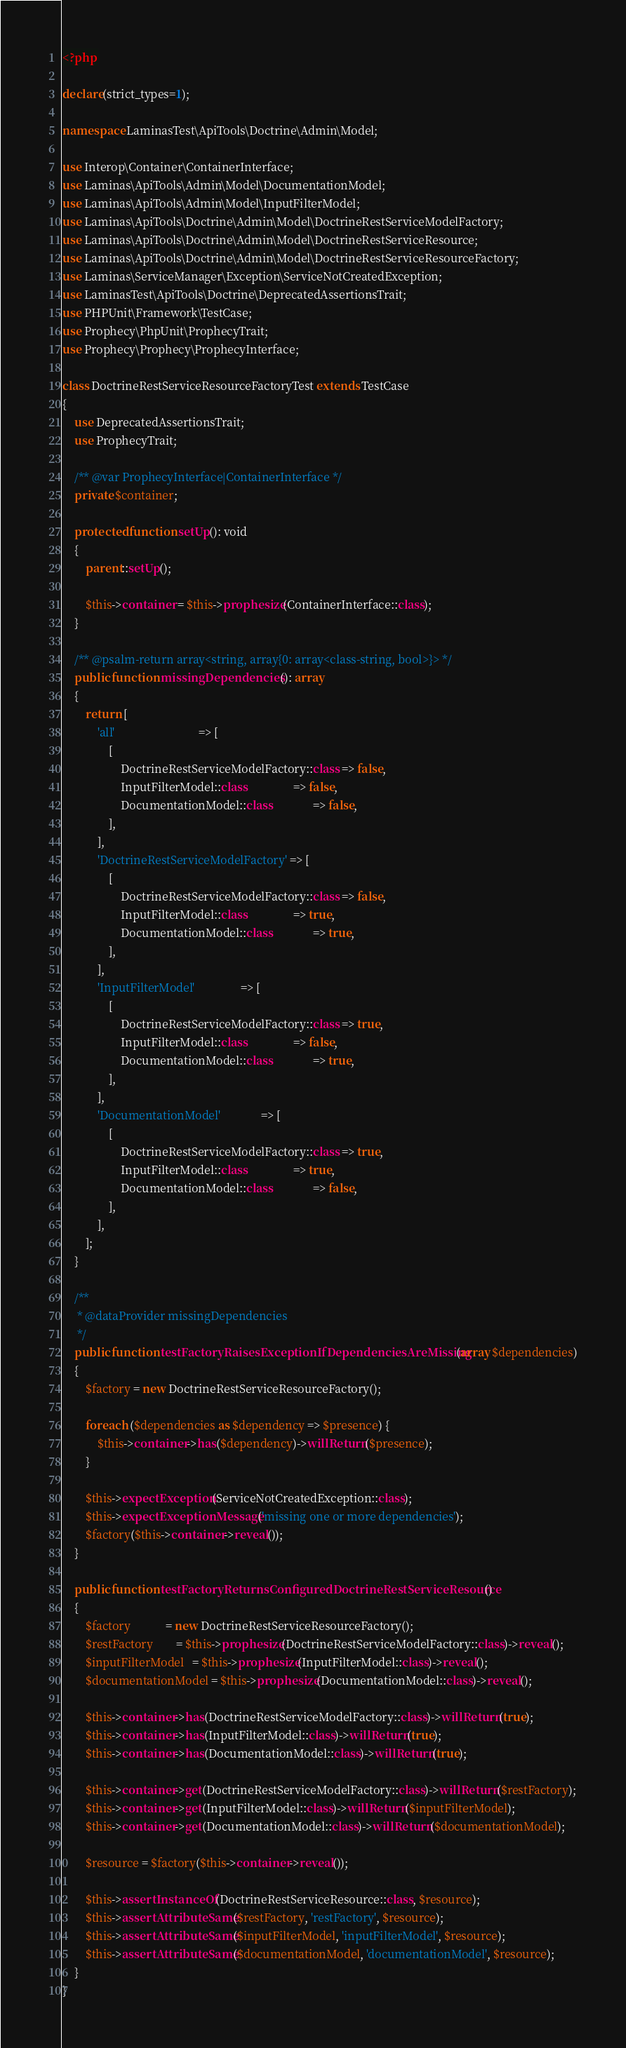<code> <loc_0><loc_0><loc_500><loc_500><_PHP_><?php

declare(strict_types=1);

namespace LaminasTest\ApiTools\Doctrine\Admin\Model;

use Interop\Container\ContainerInterface;
use Laminas\ApiTools\Admin\Model\DocumentationModel;
use Laminas\ApiTools\Admin\Model\InputFilterModel;
use Laminas\ApiTools\Doctrine\Admin\Model\DoctrineRestServiceModelFactory;
use Laminas\ApiTools\Doctrine\Admin\Model\DoctrineRestServiceResource;
use Laminas\ApiTools\Doctrine\Admin\Model\DoctrineRestServiceResourceFactory;
use Laminas\ServiceManager\Exception\ServiceNotCreatedException;
use LaminasTest\ApiTools\Doctrine\DeprecatedAssertionsTrait;
use PHPUnit\Framework\TestCase;
use Prophecy\PhpUnit\ProphecyTrait;
use Prophecy\Prophecy\ProphecyInterface;

class DoctrineRestServiceResourceFactoryTest extends TestCase
{
    use DeprecatedAssertionsTrait;
    use ProphecyTrait;

    /** @var ProphecyInterface|ContainerInterface */
    private $container;

    protected function setUp(): void
    {
        parent::setUp();

        $this->container = $this->prophesize(ContainerInterface::class);
    }

    /** @psalm-return array<string, array{0: array<class-string, bool>}> */
    public function missingDependencies(): array
    {
        return [
            'all'                             => [
                [
                    DoctrineRestServiceModelFactory::class => false,
                    InputFilterModel::class                => false,
                    DocumentationModel::class              => false,
                ],
            ],
            'DoctrineRestServiceModelFactory' => [
                [
                    DoctrineRestServiceModelFactory::class => false,
                    InputFilterModel::class                => true,
                    DocumentationModel::class              => true,
                ],
            ],
            'InputFilterModel'                => [
                [
                    DoctrineRestServiceModelFactory::class => true,
                    InputFilterModel::class                => false,
                    DocumentationModel::class              => true,
                ],
            ],
            'DocumentationModel'              => [
                [
                    DoctrineRestServiceModelFactory::class => true,
                    InputFilterModel::class                => true,
                    DocumentationModel::class              => false,
                ],
            ],
        ];
    }

    /**
     * @dataProvider missingDependencies
     */
    public function testFactoryRaisesExceptionIfDependenciesAreMissing(array $dependencies)
    {
        $factory = new DoctrineRestServiceResourceFactory();

        foreach ($dependencies as $dependency => $presence) {
            $this->container->has($dependency)->willReturn($presence);
        }

        $this->expectException(ServiceNotCreatedException::class);
        $this->expectExceptionMessage('missing one or more dependencies');
        $factory($this->container->reveal());
    }

    public function testFactoryReturnsConfiguredDoctrineRestServiceResource()
    {
        $factory            = new DoctrineRestServiceResourceFactory();
        $restFactory        = $this->prophesize(DoctrineRestServiceModelFactory::class)->reveal();
        $inputFilterModel   = $this->prophesize(InputFilterModel::class)->reveal();
        $documentationModel = $this->prophesize(DocumentationModel::class)->reveal();

        $this->container->has(DoctrineRestServiceModelFactory::class)->willReturn(true);
        $this->container->has(InputFilterModel::class)->willReturn(true);
        $this->container->has(DocumentationModel::class)->willReturn(true);

        $this->container->get(DoctrineRestServiceModelFactory::class)->willReturn($restFactory);
        $this->container->get(InputFilterModel::class)->willReturn($inputFilterModel);
        $this->container->get(DocumentationModel::class)->willReturn($documentationModel);

        $resource = $factory($this->container->reveal());

        $this->assertInstanceOf(DoctrineRestServiceResource::class, $resource);
        $this->assertAttributeSame($restFactory, 'restFactory', $resource);
        $this->assertAttributeSame($inputFilterModel, 'inputFilterModel', $resource);
        $this->assertAttributeSame($documentationModel, 'documentationModel', $resource);
    }
}
</code> 